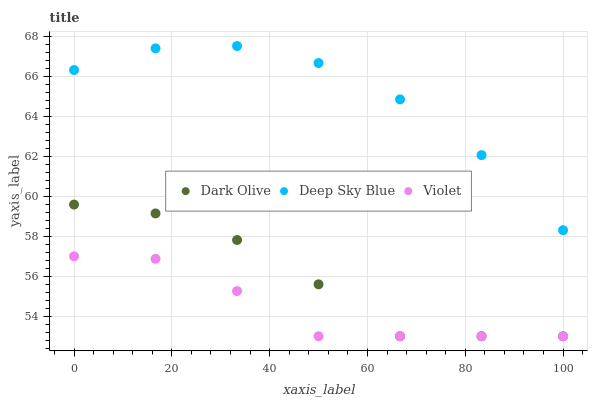Does Violet have the minimum area under the curve?
Answer yes or no. Yes. Does Deep Sky Blue have the maximum area under the curve?
Answer yes or no. Yes. Does Deep Sky Blue have the minimum area under the curve?
Answer yes or no. No. Does Violet have the maximum area under the curve?
Answer yes or no. No. Is Violet the smoothest?
Answer yes or no. Yes. Is Deep Sky Blue the roughest?
Answer yes or no. Yes. Is Deep Sky Blue the smoothest?
Answer yes or no. No. Is Violet the roughest?
Answer yes or no. No. Does Dark Olive have the lowest value?
Answer yes or no. Yes. Does Deep Sky Blue have the lowest value?
Answer yes or no. No. Does Deep Sky Blue have the highest value?
Answer yes or no. Yes. Does Violet have the highest value?
Answer yes or no. No. Is Dark Olive less than Deep Sky Blue?
Answer yes or no. Yes. Is Deep Sky Blue greater than Violet?
Answer yes or no. Yes. Does Dark Olive intersect Violet?
Answer yes or no. Yes. Is Dark Olive less than Violet?
Answer yes or no. No. Is Dark Olive greater than Violet?
Answer yes or no. No. Does Dark Olive intersect Deep Sky Blue?
Answer yes or no. No. 